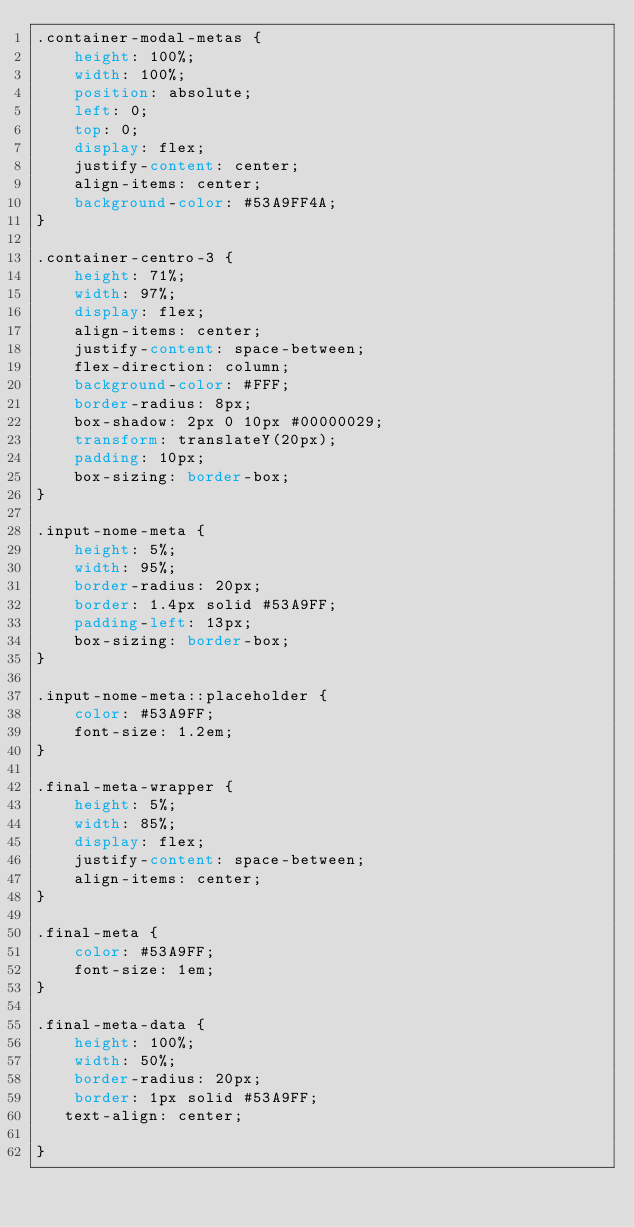Convert code to text. <code><loc_0><loc_0><loc_500><loc_500><_CSS_>.container-modal-metas {
    height: 100%;
    width: 100%;
    position: absolute;
    left: 0;
    top: 0;
    display: flex;
    justify-content: center;
    align-items: center;
    background-color: #53A9FF4A;
}

.container-centro-3 {
    height: 71%;
    width: 97%;
    display: flex;
    align-items: center;
    justify-content: space-between;
    flex-direction: column;
    background-color: #FFF;
    border-radius: 8px;
    box-shadow: 2px 0 10px #00000029;
    transform: translateY(20px);
    padding: 10px;
    box-sizing: border-box;
} 

.input-nome-meta {
    height: 5%;
    width: 95%;
    border-radius: 20px;
    border: 1.4px solid #53A9FF;
    padding-left: 13px;
    box-sizing: border-box;
}

.input-nome-meta::placeholder {
    color: #53A9FF;
    font-size: 1.2em;
}

.final-meta-wrapper {
    height: 5%;
    width: 85%;
    display: flex;
    justify-content: space-between;
    align-items: center;
}

.final-meta {
    color: #53A9FF;
    font-size: 1em;
}

.final-meta-data {
    height: 100%;
    width: 50%;
    border-radius: 20px;
    border: 1px solid #53A9FF;
   text-align: center;
     
}</code> 